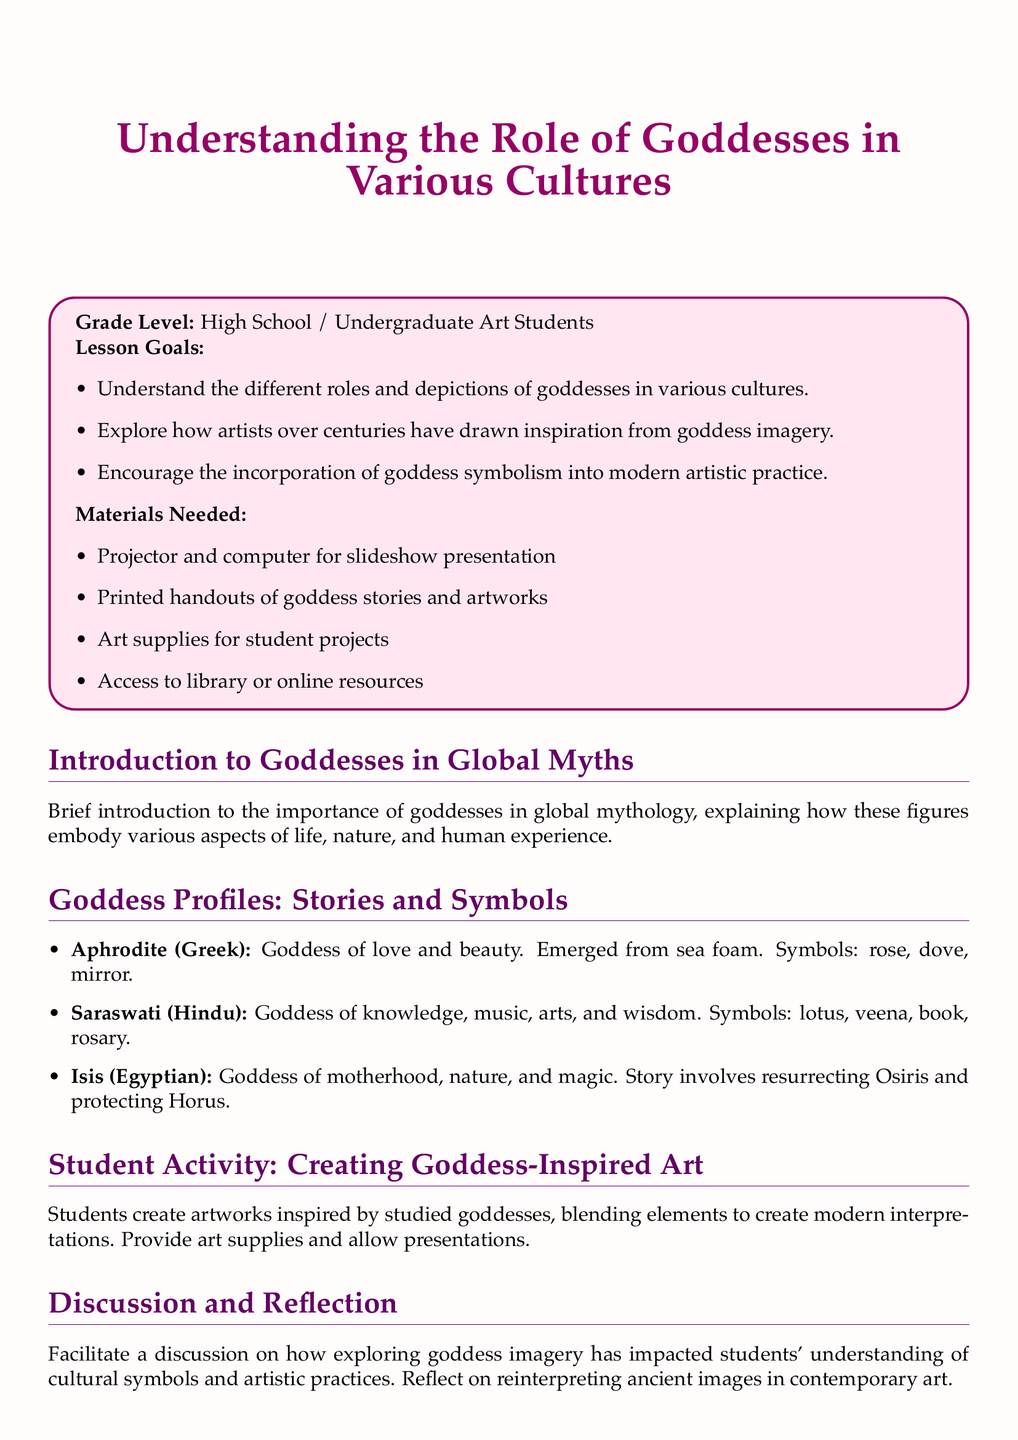What is the title of the lesson plan? The title of the lesson plan is found at the top of the document.
Answer: Understanding the Role of Goddesses in Various Cultures What grade level is this lesson plan intended for? The intended grade level is specified in the introduction section of the document.
Answer: High School / Undergraduate Art Students Which goddess is associated with love and beauty? The document lists the attributes of various goddesses in the profiles section.
Answer: Aphrodite What are the symbols associated with Saraswati? The symbols for Saraswati are mentioned in her profile under Goddess Profiles.
Answer: lotus, veena, book, rosary What is one activity included in the lesson plan? The lesson plan includes a section on student activities, outlining what students will do.
Answer: Creating Goddess-Inspired Art What is the purpose of the discussion and reflection section? The discussion and reflection section emphasizes the impact of exploration of goddess imagery.
Answer: Impact on understanding cultural symbols and artistic practices How do goddesses embody aspects of life, according to the document? The introduction to goddesses in global myths describes their significance.
Answer: Various aspects of life, nature, and human experience What is the color of the document's background? The document specifies background color in the design settings.
Answer: Light pink 